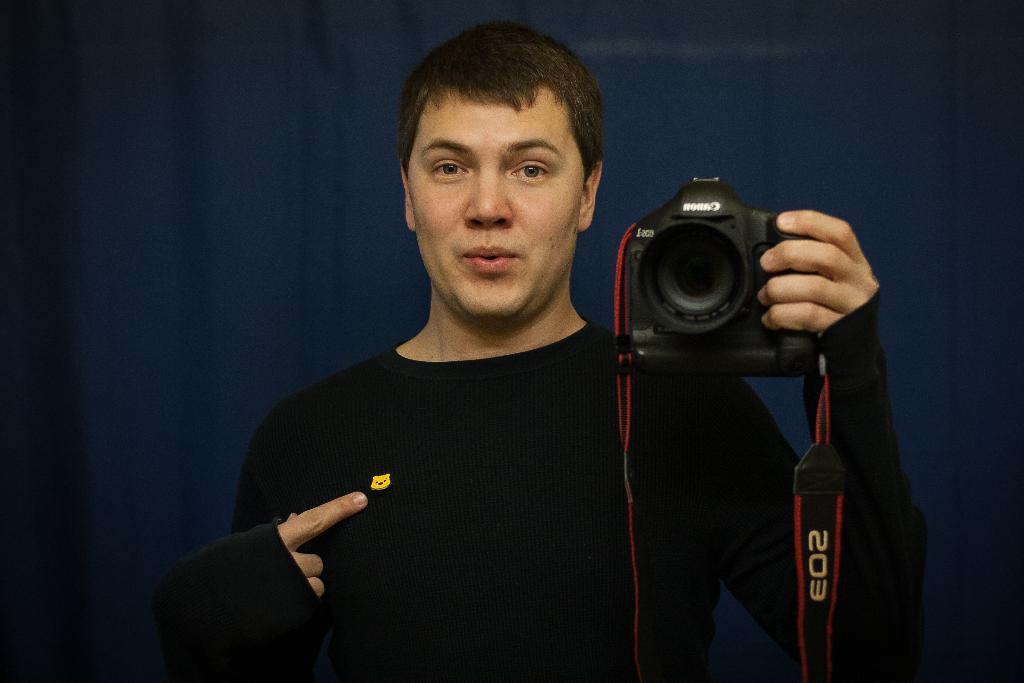Please provide a concise description of this image. In this picture man wearing a black t shirt is holding a camera. There is a blue background. 